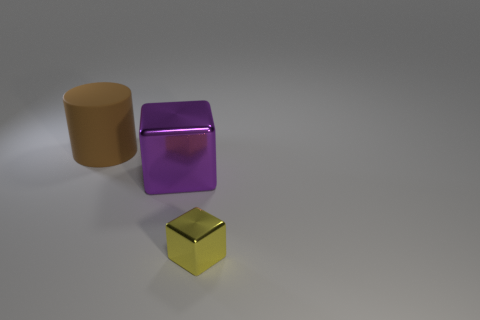Is there anything else that has the same material as the brown object?
Offer a terse response. No. Is the large purple thing made of the same material as the block on the right side of the large purple metallic thing?
Offer a very short reply. Yes. There is a thing that is in front of the large object on the right side of the large brown thing; what is its shape?
Your answer should be very brief. Cube. What number of small things are either brown cylinders or blocks?
Provide a succinct answer. 1. What number of other objects have the same shape as the small object?
Give a very brief answer. 1. There is a matte thing; is its shape the same as the shiny thing on the left side of the yellow thing?
Ensure brevity in your answer.  No. How many metallic objects are in front of the yellow metallic object?
Give a very brief answer. 0. Are there any things of the same size as the brown rubber cylinder?
Provide a short and direct response. Yes. There is a large matte object that is behind the tiny yellow shiny block; is it the same shape as the yellow shiny thing?
Ensure brevity in your answer.  No. The tiny block is what color?
Keep it short and to the point. Yellow. 